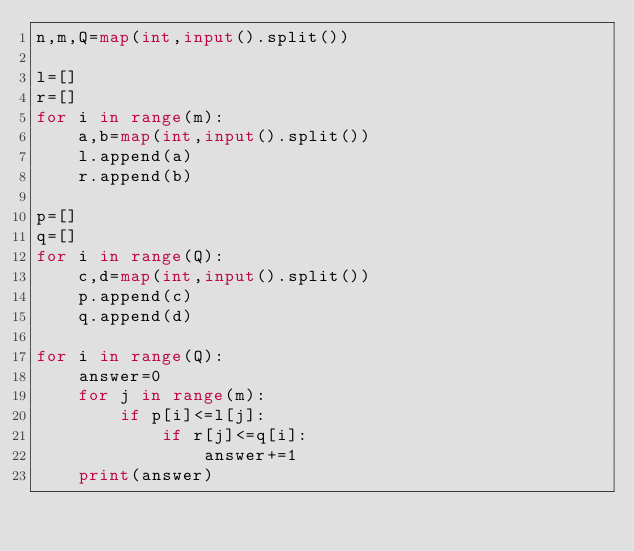<code> <loc_0><loc_0><loc_500><loc_500><_Python_>n,m,Q=map(int,input().split())

l=[]
r=[]
for i in range(m):
    a,b=map(int,input().split())
    l.append(a)
    r.append(b)

p=[]
q=[]    
for i in range(Q):
    c,d=map(int,input().split())
    p.append(c)
    q.append(d)
    
for i in range(Q):
    answer=0
    for j in range(m):
        if p[i]<=l[j]:
            if r[j]<=q[i]:
                answer+=1
    print(answer)
</code> 